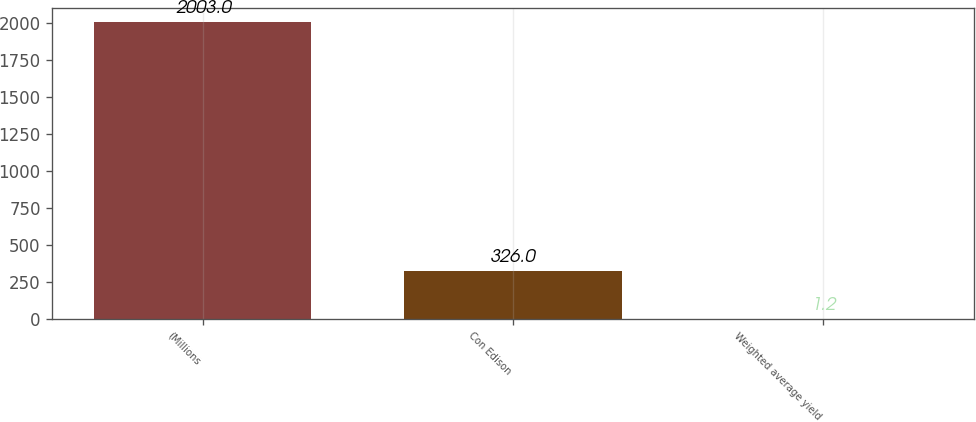Convert chart to OTSL. <chart><loc_0><loc_0><loc_500><loc_500><bar_chart><fcel>(Millions<fcel>Con Edison<fcel>Weighted average yield<nl><fcel>2003<fcel>326<fcel>1.2<nl></chart> 